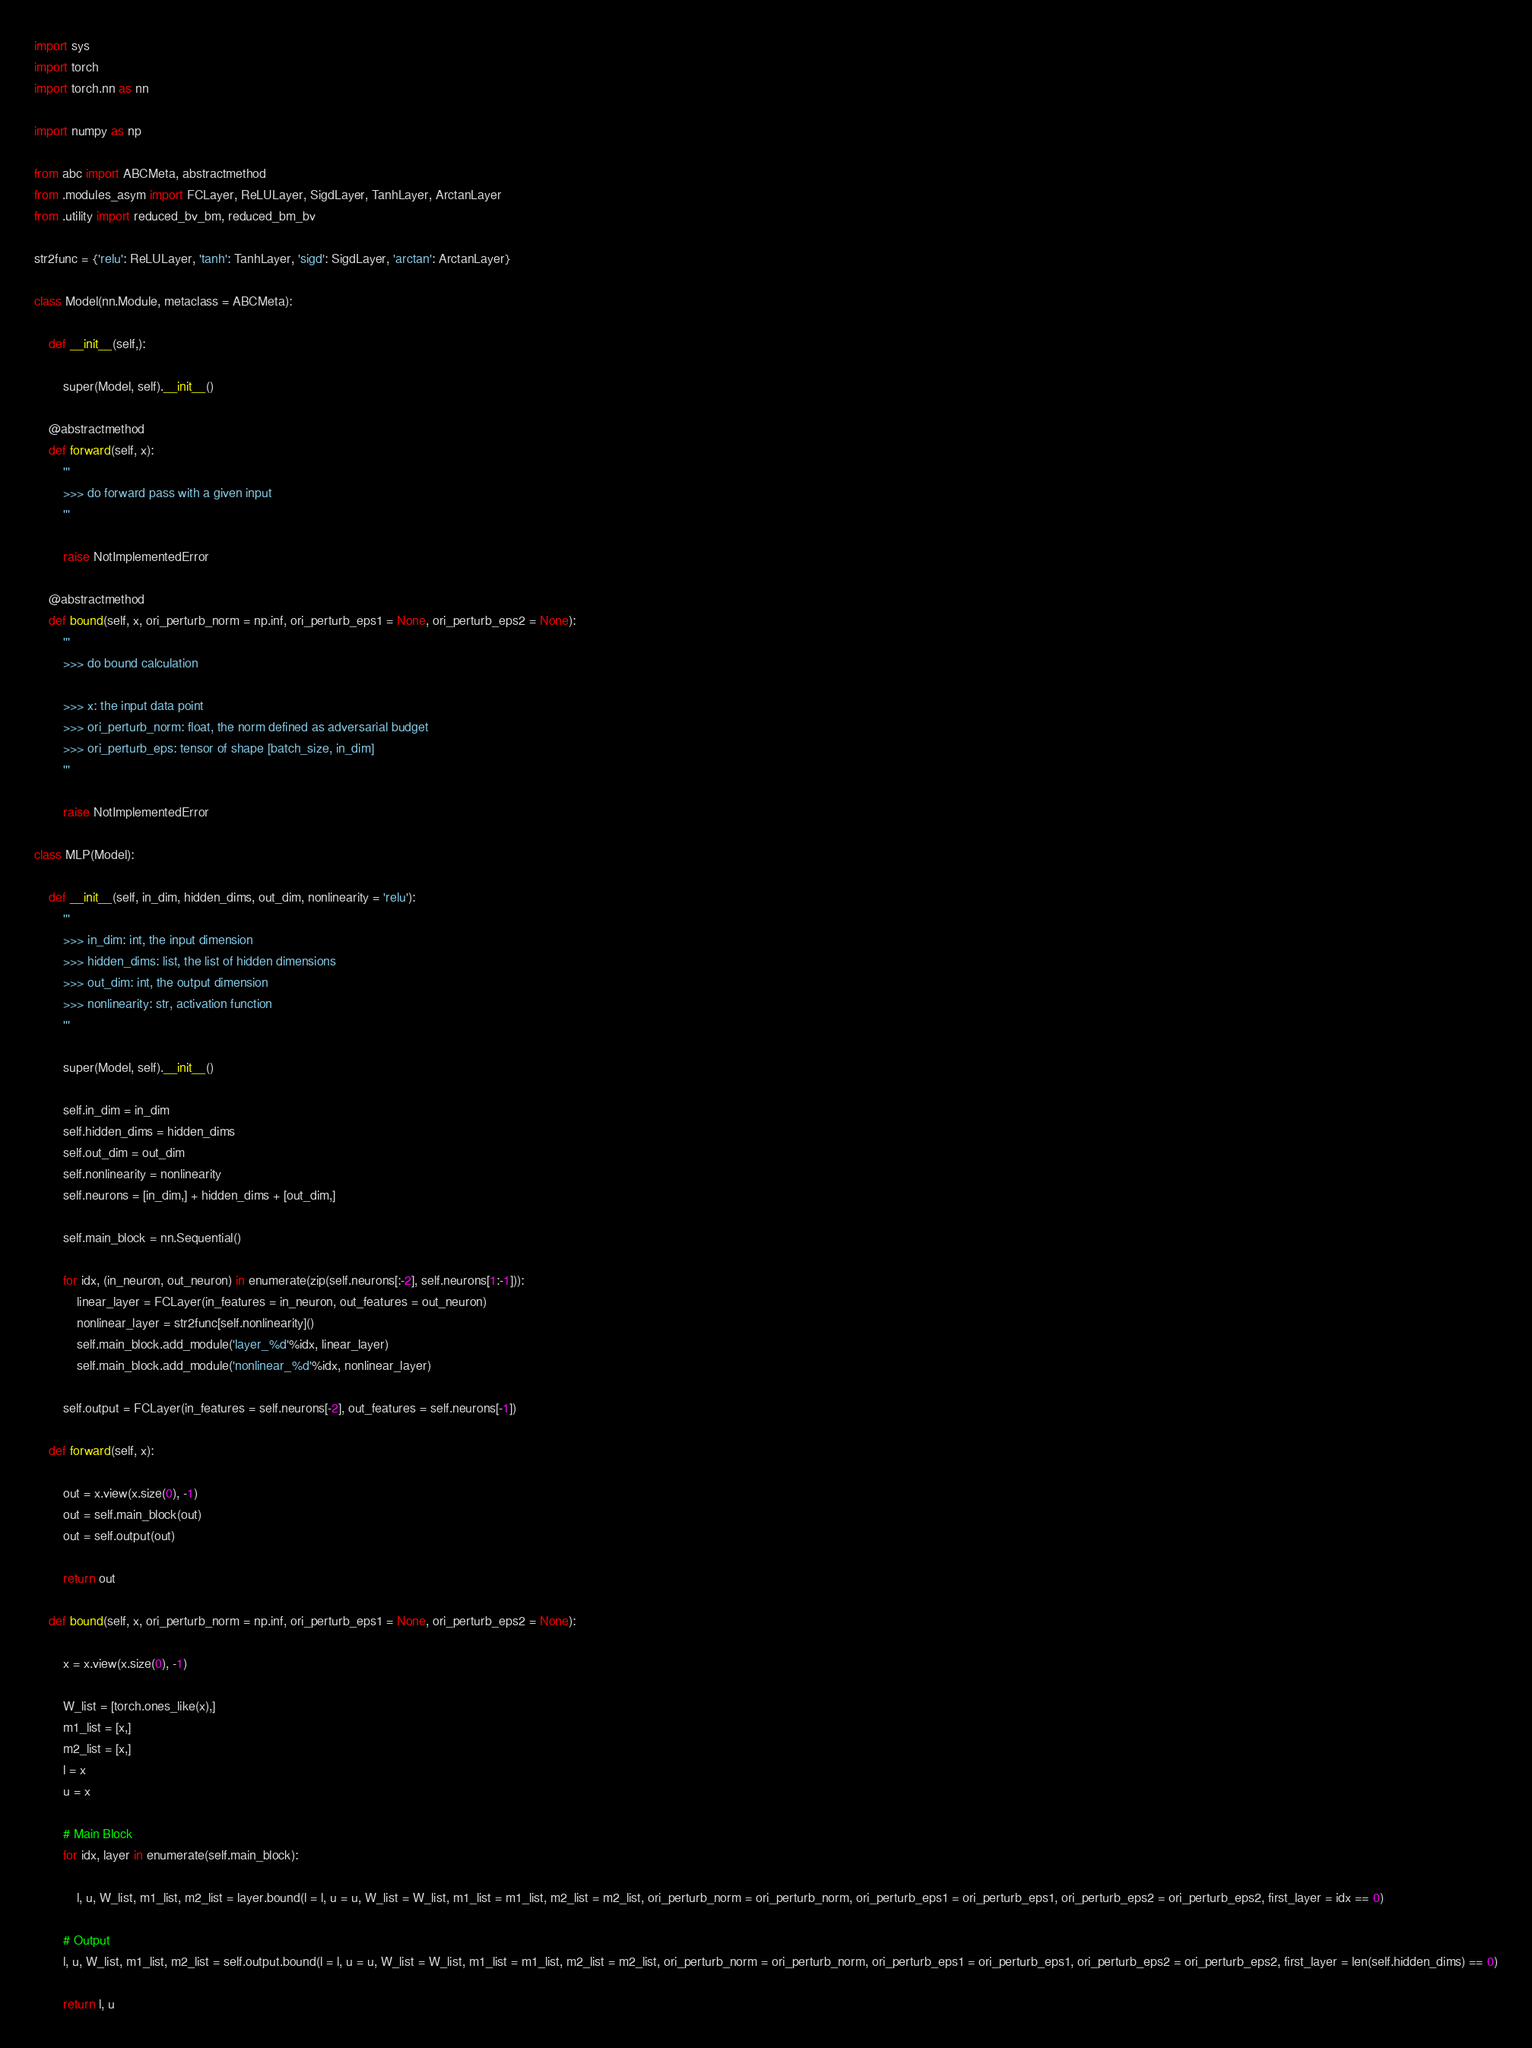<code> <loc_0><loc_0><loc_500><loc_500><_Python_>import sys
import torch
import torch.nn as nn

import numpy as np

from abc import ABCMeta, abstractmethod
from .modules_asym import FCLayer, ReLULayer, SigdLayer, TanhLayer, ArctanLayer
from .utility import reduced_bv_bm, reduced_bm_bv

str2func = {'relu': ReLULayer, 'tanh': TanhLayer, 'sigd': SigdLayer, 'arctan': ArctanLayer}

class Model(nn.Module, metaclass = ABCMeta):

    def __init__(self,):

        super(Model, self).__init__()

    @abstractmethod
    def forward(self, x):
        '''
        >>> do forward pass with a given input
        '''

        raise NotImplementedError

    @abstractmethod
    def bound(self, x, ori_perturb_norm = np.inf, ori_perturb_eps1 = None, ori_perturb_eps2 = None):
        '''
        >>> do bound calculation

        >>> x: the input data point
        >>> ori_perturb_norm: float, the norm defined as adversarial budget
        >>> ori_perturb_eps: tensor of shape [batch_size, in_dim]
        '''

        raise NotImplementedError

class MLP(Model):

    def __init__(self, in_dim, hidden_dims, out_dim, nonlinearity = 'relu'):
        '''
        >>> in_dim: int, the input dimension
        >>> hidden_dims: list, the list of hidden dimensions
        >>> out_dim: int, the output dimension
        >>> nonlinearity: str, activation function
        '''

        super(Model, self).__init__()

        self.in_dim = in_dim
        self.hidden_dims = hidden_dims
        self.out_dim = out_dim
        self.nonlinearity = nonlinearity
        self.neurons = [in_dim,] + hidden_dims + [out_dim,]

        self.main_block = nn.Sequential()

        for idx, (in_neuron, out_neuron) in enumerate(zip(self.neurons[:-2], self.neurons[1:-1])):
            linear_layer = FCLayer(in_features = in_neuron, out_features = out_neuron)
            nonlinear_layer = str2func[self.nonlinearity]()
            self.main_block.add_module('layer_%d'%idx, linear_layer)
            self.main_block.add_module('nonlinear_%d'%idx, nonlinear_layer)

        self.output = FCLayer(in_features = self.neurons[-2], out_features = self.neurons[-1])

    def forward(self, x):

        out = x.view(x.size(0), -1)
        out = self.main_block(out)
        out = self.output(out)

        return out

    def bound(self, x, ori_perturb_norm = np.inf, ori_perturb_eps1 = None, ori_perturb_eps2 = None):

        x = x.view(x.size(0), -1)

        W_list = [torch.ones_like(x),]
        m1_list = [x,]
        m2_list = [x,]
        l = x
        u = x

        # Main Block
        for idx, layer in enumerate(self.main_block):

            l, u, W_list, m1_list, m2_list = layer.bound(l = l, u = u, W_list = W_list, m1_list = m1_list, m2_list = m2_list, ori_perturb_norm = ori_perturb_norm, ori_perturb_eps1 = ori_perturb_eps1, ori_perturb_eps2 = ori_perturb_eps2, first_layer = idx == 0)

        # Output
        l, u, W_list, m1_list, m2_list = self.output.bound(l = l, u = u, W_list = W_list, m1_list = m1_list, m2_list = m2_list, ori_perturb_norm = ori_perturb_norm, ori_perturb_eps1 = ori_perturb_eps1, ori_perturb_eps2 = ori_perturb_eps2, first_layer = len(self.hidden_dims) == 0)

        return l, u
</code> 